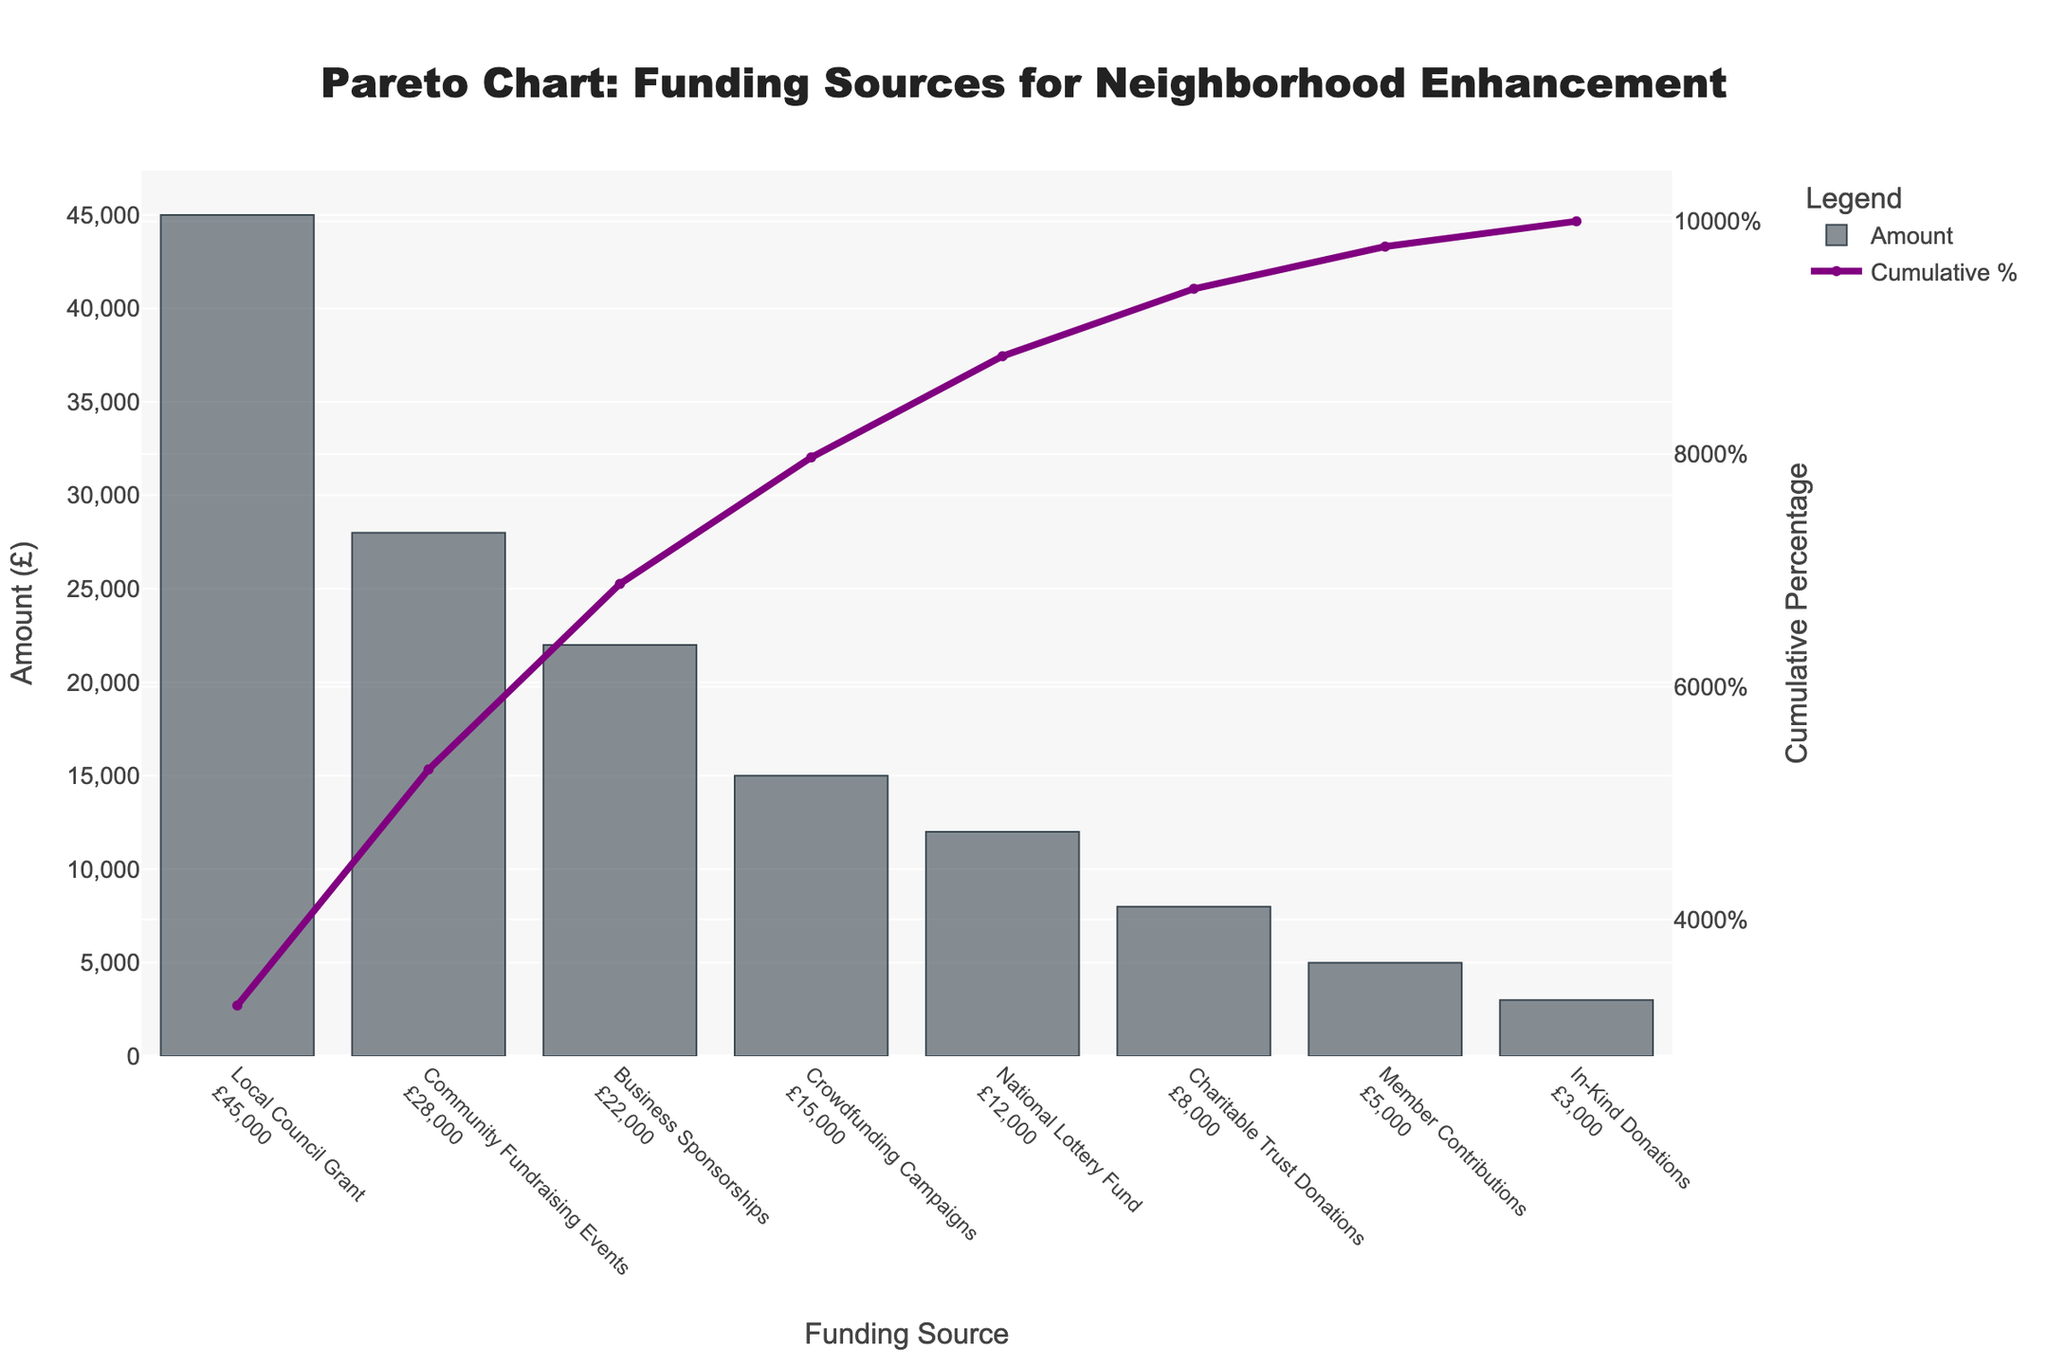What's the largest funding source? The largest bar on the chart represents the largest funding source. From the chart, it's clear that the "Local Council Grant" has the highest amount.
Answer: Local Council Grant What is the total amount of funding received from the top three sources? The top three sources are "Local Council Grant," "Community Fundraising Events," and "Business Sponsorships." Summing their amounts: £45,000 + £28,000 + £22,000 = £95,000.
Answer: £95,000 How much more does the Local Council Grant provide compared to Community Fundraising Events? The Local Council Grant provides £45,000, while Community Fundraising Events provide £28,000. The difference is £45,000 - £28,000 = £17,000.
Answer: £17,000 What percentage of the total funding is provided by Business Sponsorships? The amount provided by Business Sponsorships is £22,000. To find the percentage, divide this by the total funding and multiply by 100. Total funding is £148,000. So, (£22,000/£148,000) * 100 ≈ 14.86%.
Answer: 14.86% At what cumulative percentage is the funding from National Lottery Fund? Look at the line corresponding to "National Lottery Fund" on the chart. The cumulative percentage for the National Lottery Fund is around 80%.
Answer: ~80% Which funding source represents the cumulative percentage closest to 50%? The funding source corresponding to around 50% on the cumulative percentage line is "Business Sponsorships."
Answer: Business Sponsorships How many funding sources are shown in the chart? Count the number of bars on the chart. There are 8 funding sources indicated.
Answer: 8 What is the cumulative percentage of funding by the fourth-largest source? The fourth-largest source is "Crowdfunding Campaigns," and the cumulative percentage shown at this source is around 74%.
Answer: ~74% What is the contribution of the smallest funding source? The smallest funding source is "In-Kind Donations," as represented by the shortest bar, with an amount of £3,000.
Answer: £3,000 